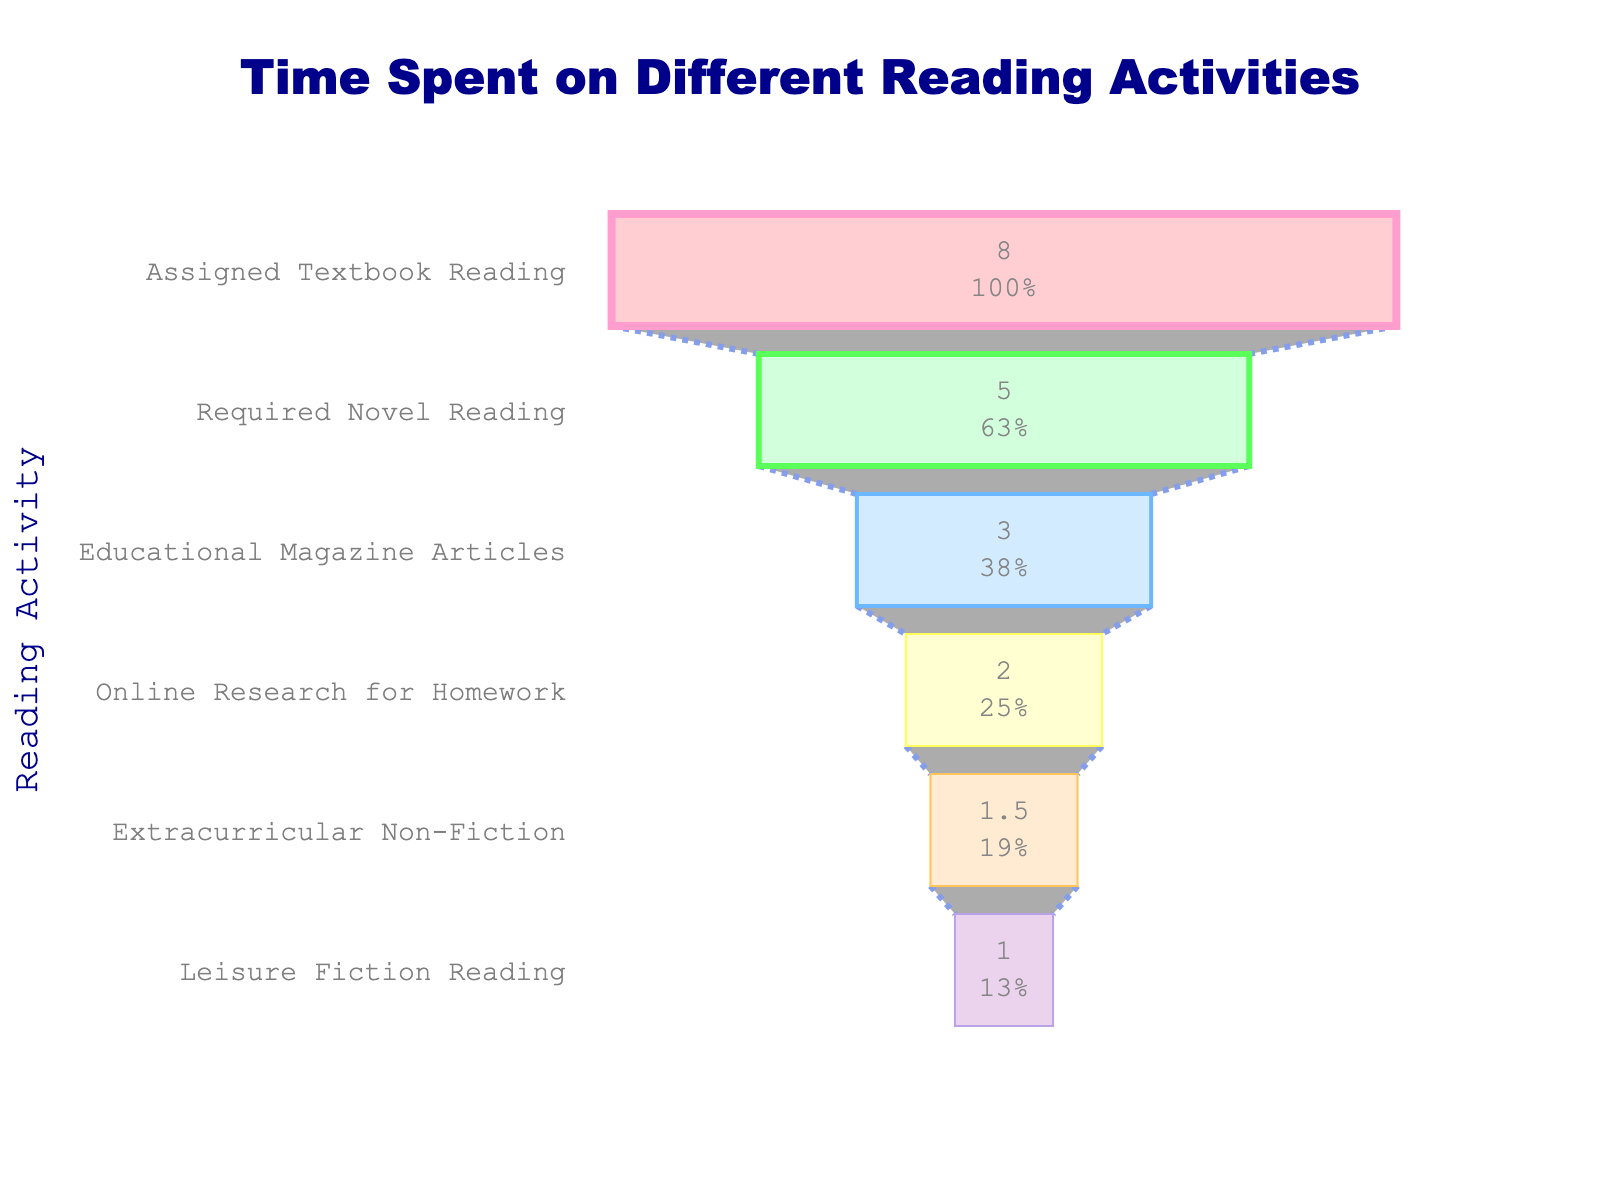What is the title of the funnel chart? The title of the chart is usually placed prominently at the top to provide an overview of the displayed data.
Answer: Time Spent on Different Reading Activities What activity has the highest number of hours per week? The activity with the highest bar in the funnel indicates the highest number of hours per week.
Answer: Assigned Textbook Reading How many hours per week are spent on Leisure Fiction Reading? Locate the bar labeled "Leisure Fiction Reading" and read the corresponding value.
Answer: 1 hour Which activity has the least amount of time spent per week? The activity at the narrowest part of the funnel chart represents the least amount of time spent.
Answer: Leisure Fiction Reading What is the combined time spent on Required Novel Reading and Extracurricular Non-Fiction? Add the hours spent on Required Novel Reading (5) and Extracurricular Non-Fiction (1.5).
Answer: 6.5 hours How many reading activities are displayed in the funnel chart? Count the number of distinct bars representing different activities.
Answer: 6 activities Which activity takes more time: Online Research for Homework or Educational Magazine Articles? Compare the lengths of the bars for "Online Research for Homework" and "Educational Magazine Articles".
Answer: Educational Magazine Articles What percentage of the total time is spent on Assigned Textbook Reading? The chart displays percentages inside the bars. Refer to the percentage shown for "Assigned Textbook Reading".
Answer: Approximately 47.1% What is the difference in hours per week between the activity with the most time and the activity with the least time? Subtract the hours for Leisure Fiction Reading (1) from the hours for Assigned Textbook Reading (8).
Answer: 7 hours What are the colors used for the "Online Research for Homework" activity? Identify the color of the bar labeled "Online Research for Homework". In this case, the bar's color is described.
Answer: Yellow with a yellow outline 